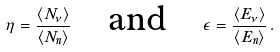<formula> <loc_0><loc_0><loc_500><loc_500>\eta = \frac { \langle N _ { \nu } \rangle } { \langle N _ { n } \rangle } \quad \text {and} \quad \epsilon = \frac { \langle E _ { \nu } \rangle } { \langle E _ { n } \rangle } \, .</formula> 